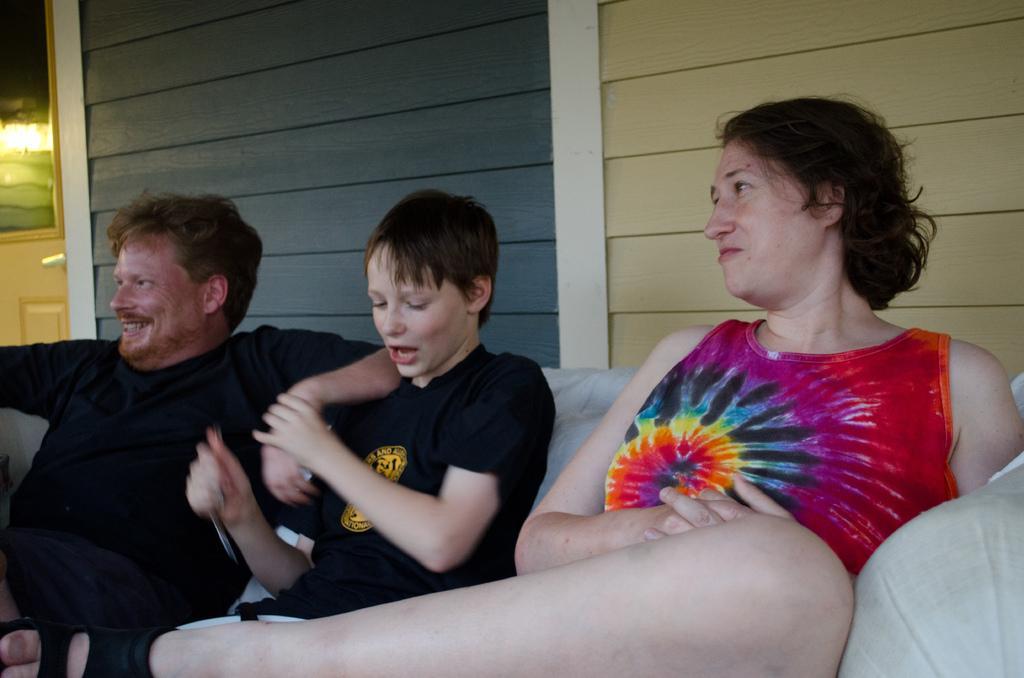Please provide a concise description of this image. In this image I can see on the right side there is a woman sitting on the sofa, beside her two persons are sitting and laughing, they wore black color t-shirts. 